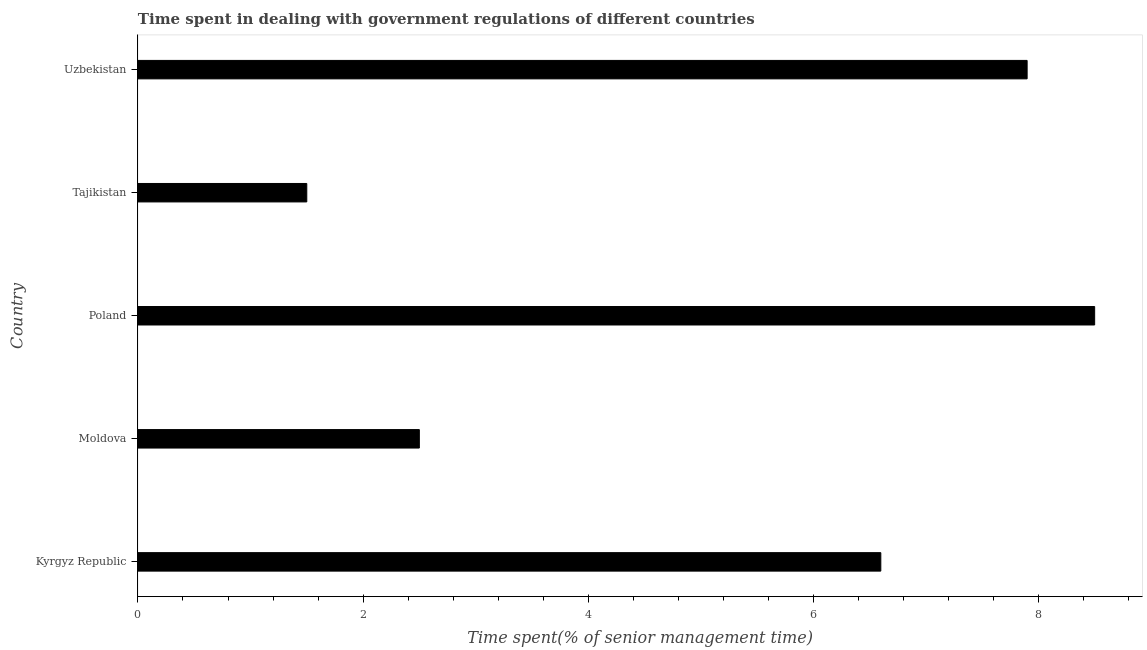Does the graph contain any zero values?
Keep it short and to the point. No. What is the title of the graph?
Provide a succinct answer. Time spent in dealing with government regulations of different countries. What is the label or title of the X-axis?
Make the answer very short. Time spent(% of senior management time). What is the label or title of the Y-axis?
Offer a terse response. Country. In which country was the time spent in dealing with government regulations maximum?
Your answer should be very brief. Poland. In which country was the time spent in dealing with government regulations minimum?
Your answer should be very brief. Tajikistan. What is the difference between the time spent in dealing with government regulations in Kyrgyz Republic and Moldova?
Make the answer very short. 4.1. What is the median time spent in dealing with government regulations?
Provide a short and direct response. 6.6. What is the ratio of the time spent in dealing with government regulations in Tajikistan to that in Uzbekistan?
Offer a very short reply. 0.19. Is the time spent in dealing with government regulations in Poland less than that in Tajikistan?
Your response must be concise. No. What is the Time spent(% of senior management time) of Kyrgyz Republic?
Offer a terse response. 6.6. What is the Time spent(% of senior management time) in Moldova?
Make the answer very short. 2.5. What is the Time spent(% of senior management time) in Poland?
Give a very brief answer. 8.5. What is the difference between the Time spent(% of senior management time) in Kyrgyz Republic and Uzbekistan?
Your response must be concise. -1.3. What is the difference between the Time spent(% of senior management time) in Moldova and Tajikistan?
Give a very brief answer. 1. What is the difference between the Time spent(% of senior management time) in Moldova and Uzbekistan?
Ensure brevity in your answer.  -5.4. What is the difference between the Time spent(% of senior management time) in Poland and Tajikistan?
Offer a terse response. 7. What is the difference between the Time spent(% of senior management time) in Tajikistan and Uzbekistan?
Give a very brief answer. -6.4. What is the ratio of the Time spent(% of senior management time) in Kyrgyz Republic to that in Moldova?
Offer a terse response. 2.64. What is the ratio of the Time spent(% of senior management time) in Kyrgyz Republic to that in Poland?
Make the answer very short. 0.78. What is the ratio of the Time spent(% of senior management time) in Kyrgyz Republic to that in Uzbekistan?
Make the answer very short. 0.83. What is the ratio of the Time spent(% of senior management time) in Moldova to that in Poland?
Your answer should be compact. 0.29. What is the ratio of the Time spent(% of senior management time) in Moldova to that in Tajikistan?
Keep it short and to the point. 1.67. What is the ratio of the Time spent(% of senior management time) in Moldova to that in Uzbekistan?
Make the answer very short. 0.32. What is the ratio of the Time spent(% of senior management time) in Poland to that in Tajikistan?
Give a very brief answer. 5.67. What is the ratio of the Time spent(% of senior management time) in Poland to that in Uzbekistan?
Your response must be concise. 1.08. What is the ratio of the Time spent(% of senior management time) in Tajikistan to that in Uzbekistan?
Your answer should be very brief. 0.19. 